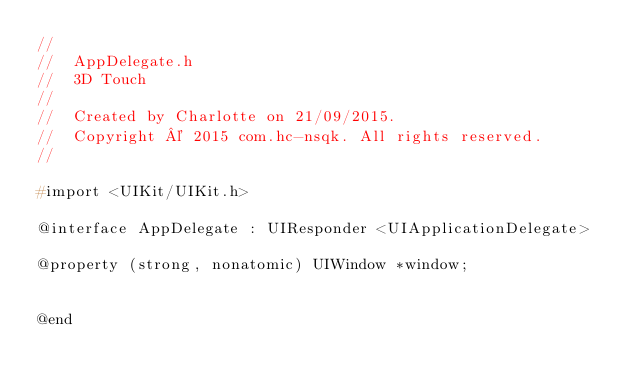<code> <loc_0><loc_0><loc_500><loc_500><_C_>//
//  AppDelegate.h
//  3D Touch
//
//  Created by Charlotte on 21/09/2015.
//  Copyright © 2015 com.hc-nsqk. All rights reserved.
//

#import <UIKit/UIKit.h>

@interface AppDelegate : UIResponder <UIApplicationDelegate>

@property (strong, nonatomic) UIWindow *window;


@end

</code> 